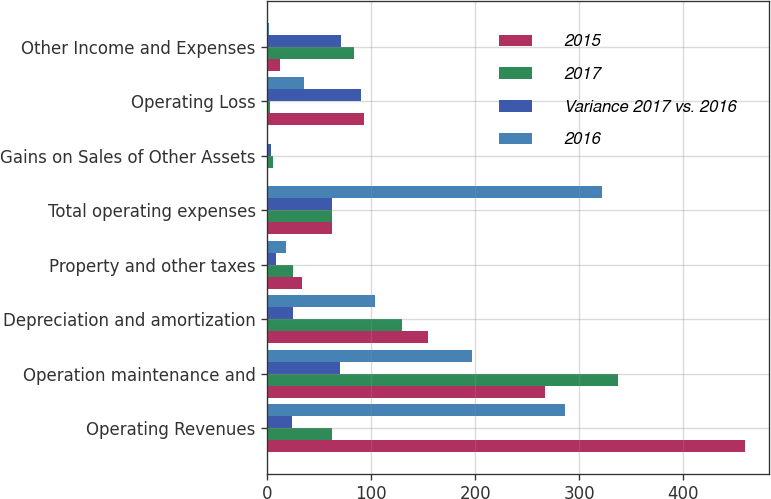<chart> <loc_0><loc_0><loc_500><loc_500><stacked_bar_chart><ecel><fcel>Operating Revenues<fcel>Operation maintenance and<fcel>Depreciation and amortization<fcel>Property and other taxes<fcel>Total operating expenses<fcel>Gains on Sales of Other Assets<fcel>Operating Loss<fcel>Other Income and Expenses<nl><fcel>2015<fcel>460<fcel>267<fcel>155<fcel>33<fcel>62<fcel>1<fcel>93<fcel>12<nl><fcel>2017<fcel>62<fcel>337<fcel>130<fcel>25<fcel>62<fcel>5<fcel>3<fcel>83<nl><fcel>Variance 2017 vs. 2016<fcel>24<fcel>70<fcel>25<fcel>8<fcel>62<fcel>4<fcel>90<fcel>71<nl><fcel>2016<fcel>286<fcel>197<fcel>104<fcel>18<fcel>322<fcel>1<fcel>35<fcel>2<nl></chart> 